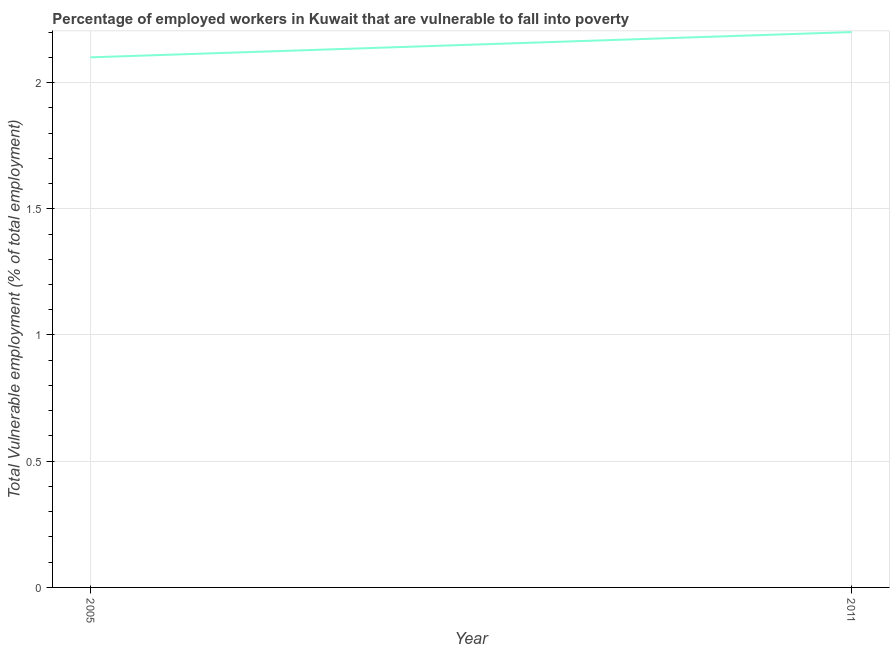What is the total vulnerable employment in 2011?
Your response must be concise. 2.2. Across all years, what is the maximum total vulnerable employment?
Make the answer very short. 2.2. Across all years, what is the minimum total vulnerable employment?
Your response must be concise. 2.1. In which year was the total vulnerable employment maximum?
Your answer should be compact. 2011. What is the sum of the total vulnerable employment?
Your response must be concise. 4.3. What is the difference between the total vulnerable employment in 2005 and 2011?
Offer a terse response. -0.1. What is the average total vulnerable employment per year?
Provide a short and direct response. 2.15. What is the median total vulnerable employment?
Your answer should be compact. 2.15. What is the ratio of the total vulnerable employment in 2005 to that in 2011?
Offer a terse response. 0.95. Are the values on the major ticks of Y-axis written in scientific E-notation?
Make the answer very short. No. Does the graph contain grids?
Ensure brevity in your answer.  Yes. What is the title of the graph?
Provide a succinct answer. Percentage of employed workers in Kuwait that are vulnerable to fall into poverty. What is the label or title of the X-axis?
Your answer should be very brief. Year. What is the label or title of the Y-axis?
Offer a very short reply. Total Vulnerable employment (% of total employment). What is the Total Vulnerable employment (% of total employment) in 2005?
Provide a short and direct response. 2.1. What is the Total Vulnerable employment (% of total employment) in 2011?
Your response must be concise. 2.2. What is the ratio of the Total Vulnerable employment (% of total employment) in 2005 to that in 2011?
Offer a terse response. 0.95. 